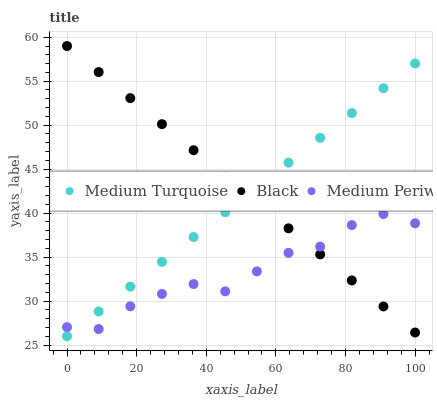Does Medium Periwinkle have the minimum area under the curve?
Answer yes or no. Yes. Does Black have the maximum area under the curve?
Answer yes or no. Yes. Does Medium Turquoise have the minimum area under the curve?
Answer yes or no. No. Does Medium Turquoise have the maximum area under the curve?
Answer yes or no. No. Is Black the smoothest?
Answer yes or no. Yes. Is Medium Periwinkle the roughest?
Answer yes or no. Yes. Is Medium Turquoise the smoothest?
Answer yes or no. No. Is Medium Turquoise the roughest?
Answer yes or no. No. Does Medium Turquoise have the lowest value?
Answer yes or no. Yes. Does Black have the lowest value?
Answer yes or no. No. Does Black have the highest value?
Answer yes or no. Yes. Does Medium Turquoise have the highest value?
Answer yes or no. No. Does Medium Periwinkle intersect Black?
Answer yes or no. Yes. Is Medium Periwinkle less than Black?
Answer yes or no. No. Is Medium Periwinkle greater than Black?
Answer yes or no. No. 